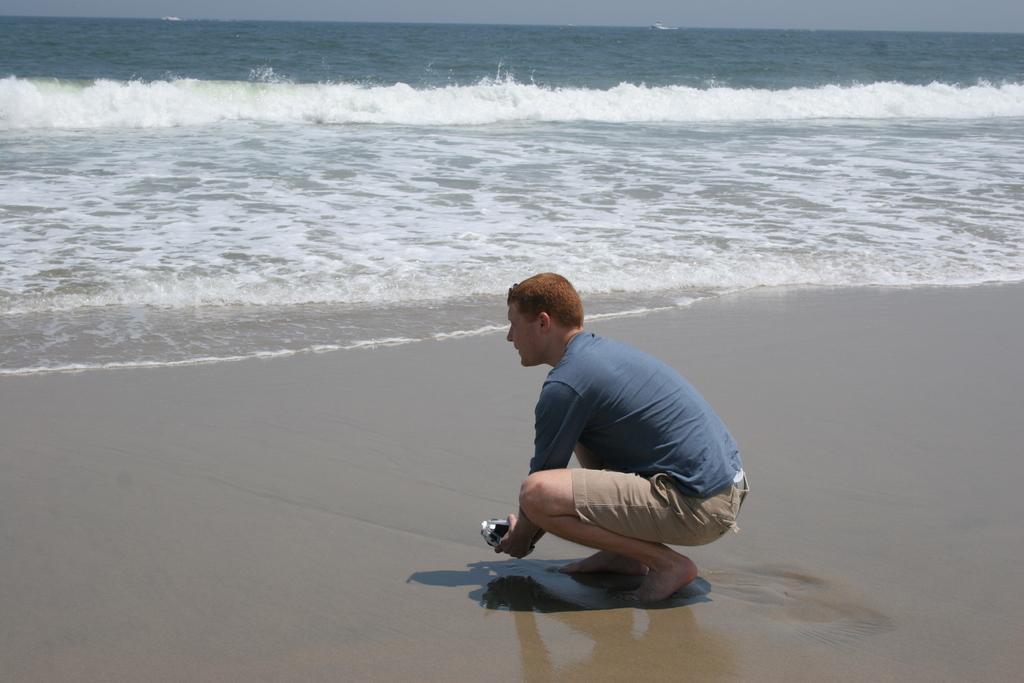How would you summarize this image in a sentence or two? In this image we can see this person wearing a blue T-shirt is on the sand and in the squat position. Here we can see waves, water and sky in the background. 